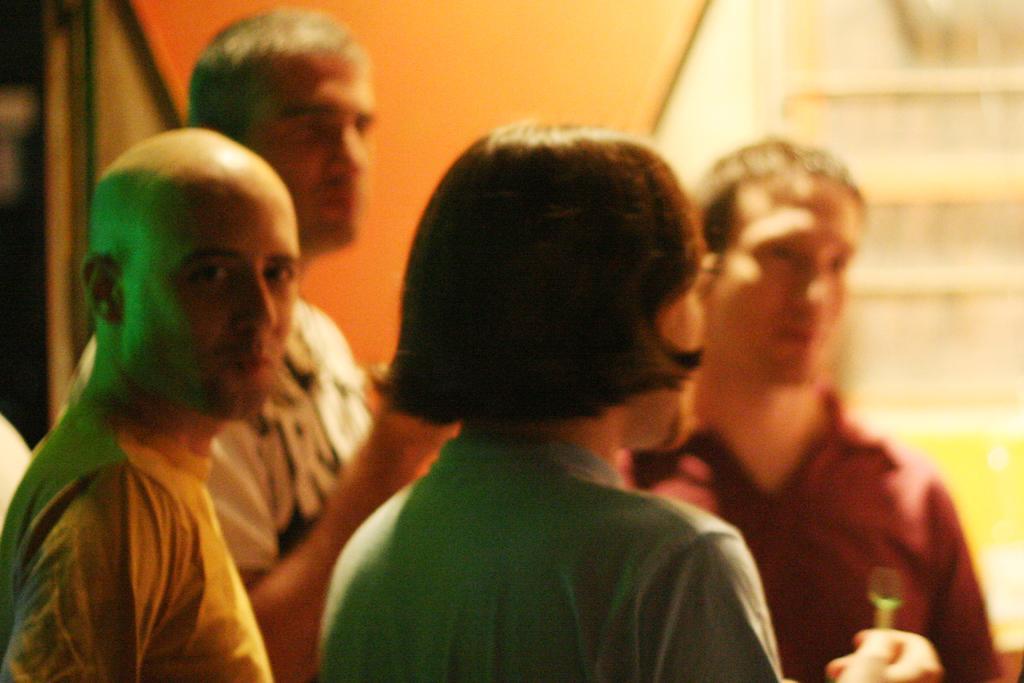Please provide a concise description of this image. Here I can see four people. Three are men and one is woman. This woman and two men are looking at the right side. The man who is standing on the left side is giving pose for the picture. The background is blurred. 